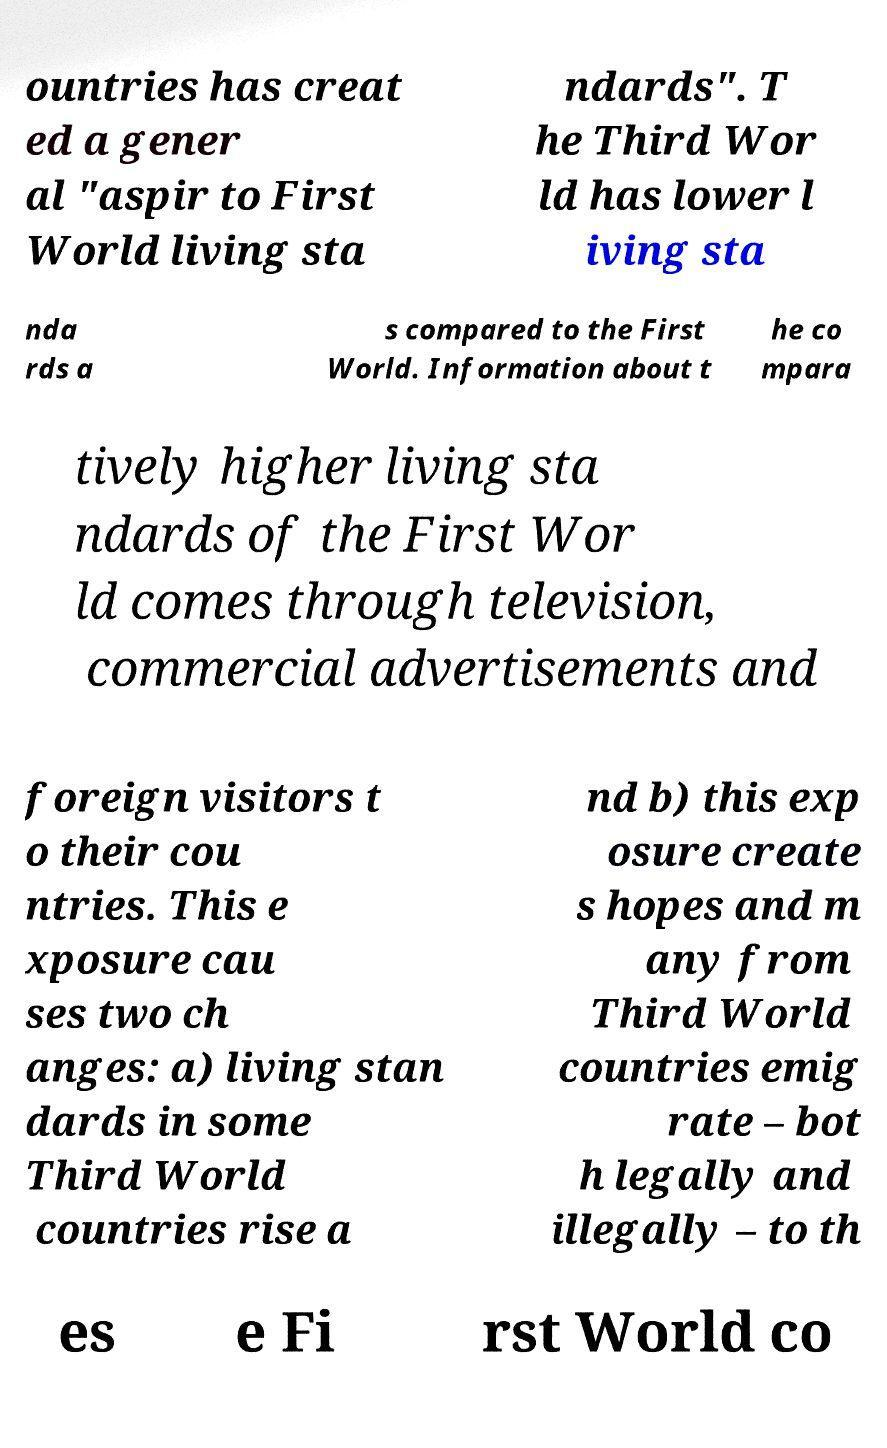Please read and relay the text visible in this image. What does it say? ountries has creat ed a gener al "aspir to First World living sta ndards". T he Third Wor ld has lower l iving sta nda rds a s compared to the First World. Information about t he co mpara tively higher living sta ndards of the First Wor ld comes through television, commercial advertisements and foreign visitors t o their cou ntries. This e xposure cau ses two ch anges: a) living stan dards in some Third World countries rise a nd b) this exp osure create s hopes and m any from Third World countries emig rate – bot h legally and illegally – to th es e Fi rst World co 